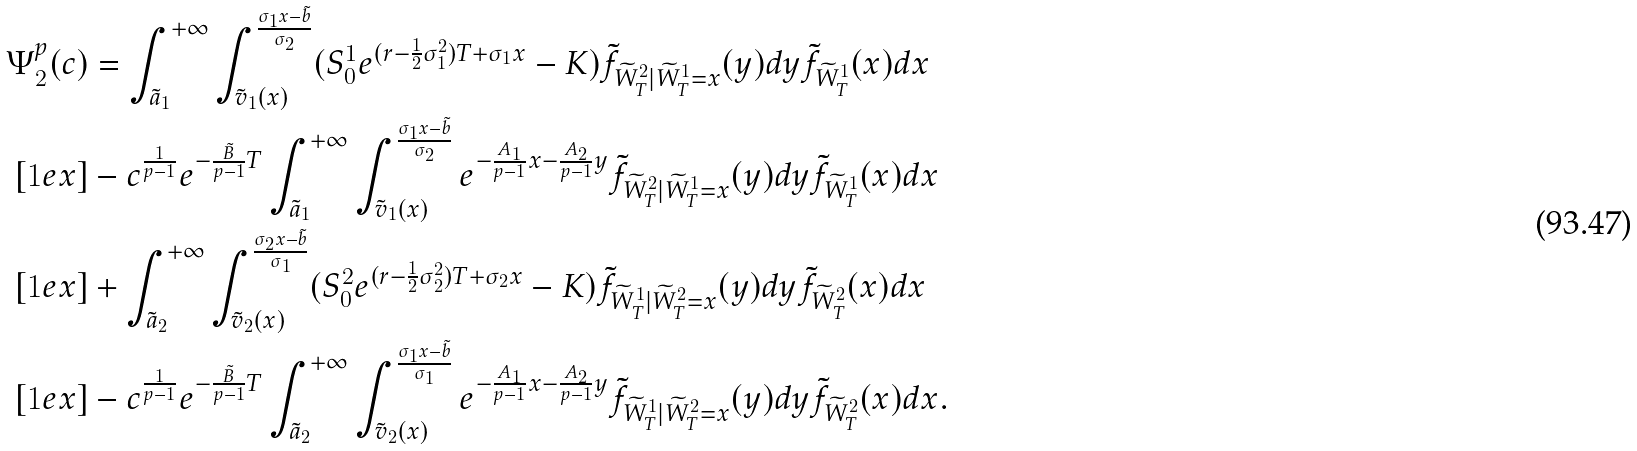<formula> <loc_0><loc_0><loc_500><loc_500>\Psi ^ { p } _ { 2 } ( c ) & = \int _ { \tilde { a } _ { 1 } } ^ { + \infty } \int _ { \tilde { v } _ { 1 } ( x ) } ^ { \frac { \sigma _ { 1 } x - \tilde { b } } { \sigma _ { 2 } } } ( S ^ { 1 } _ { 0 } e ^ { ( r - \frac { 1 } { 2 } \sigma _ { 1 } ^ { 2 } ) T + \sigma _ { 1 } x } - K ) \tilde { f } _ { \widetilde { W } ^ { 2 } _ { T } | \widetilde { W } ^ { 1 } _ { T } = x } ( y ) d y \tilde { f } _ { \widetilde { W } ^ { 1 } _ { T } } ( x ) d x \\ [ 1 e x ] & - c ^ { \frac { 1 } { p - 1 } } e ^ { - \frac { \tilde { B } } { p - 1 } T } \int _ { \tilde { a } _ { 1 } } ^ { + \infty } \int _ { \tilde { v } _ { 1 } ( x ) } ^ { \frac { \sigma _ { 1 } x - \tilde { b } } { \sigma _ { 2 } } } e ^ { - \frac { A _ { 1 } } { p - 1 } x - \frac { A _ { 2 } } { p - 1 } y } \tilde { f } _ { \widetilde { W } ^ { 2 } _ { T } | \widetilde { W } ^ { 1 } _ { T } = x } ( y ) d y \tilde { f } _ { \widetilde { W } ^ { 1 } _ { T } } ( x ) d x \\ [ 1 e x ] & + \int _ { \tilde { a } _ { 2 } } ^ { + \infty } \int _ { \tilde { v } _ { 2 } ( x ) } ^ { \frac { \sigma _ { 2 } x - \tilde { b } } { \sigma _ { 1 } } } ( S ^ { 2 } _ { 0 } e ^ { ( r - \frac { 1 } { 2 } \sigma _ { 2 } ^ { 2 } ) T + \sigma _ { 2 } x } - K ) \tilde { f } _ { \widetilde { W } ^ { 1 } _ { T } | \widetilde { W } ^ { 2 } _ { T } = x } ( y ) d y \tilde { f } _ { \widetilde { W } ^ { 2 } _ { T } } ( x ) d x \\ [ 1 e x ] & - c ^ { \frac { 1 } { p - 1 } } e ^ { - \frac { \tilde { B } } { p - 1 } T } \int _ { \tilde { a } _ { 2 } } ^ { + \infty } \int _ { \tilde { v } _ { 2 } ( x ) } ^ { \frac { \sigma _ { 1 } x - \tilde { b } } { \sigma _ { 1 } } } e ^ { - \frac { A _ { 1 } } { p - 1 } x - \frac { A _ { 2 } } { p - 1 } y } \tilde { f } _ { \widetilde { W } ^ { 1 } _ { T } | \widetilde { W } ^ { 2 } _ { T } = x } ( y ) d y \tilde { f } _ { \widetilde { W } ^ { 2 } _ { T } } ( x ) d x .</formula> 